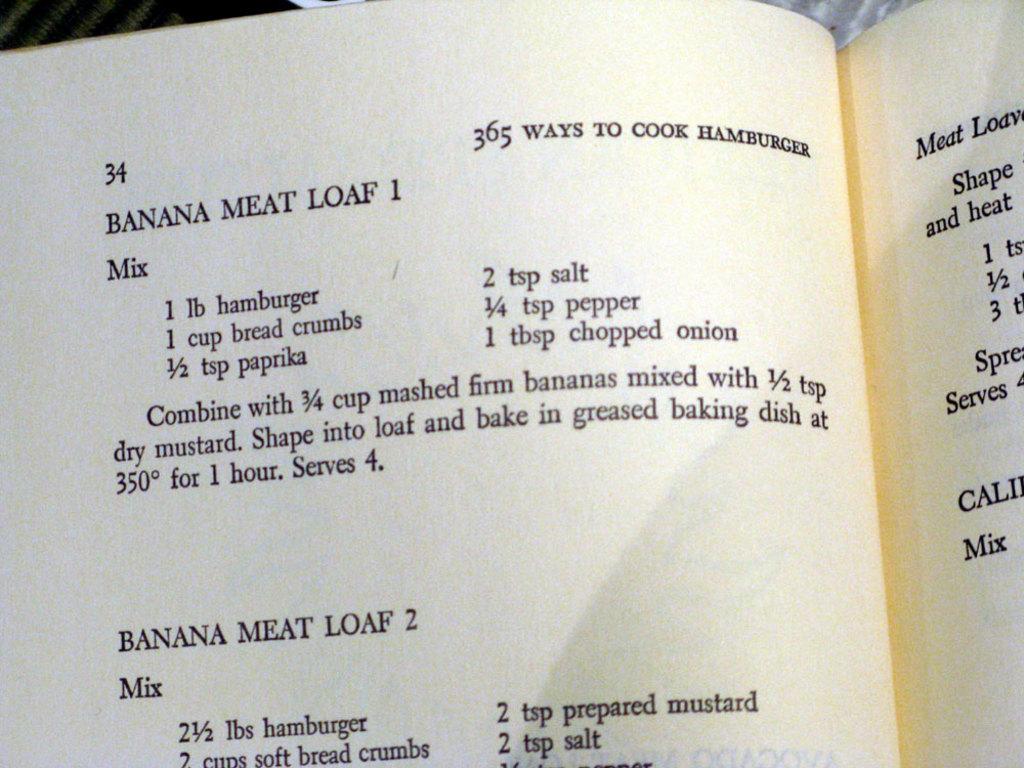What page number is this?
Ensure brevity in your answer.  34. 